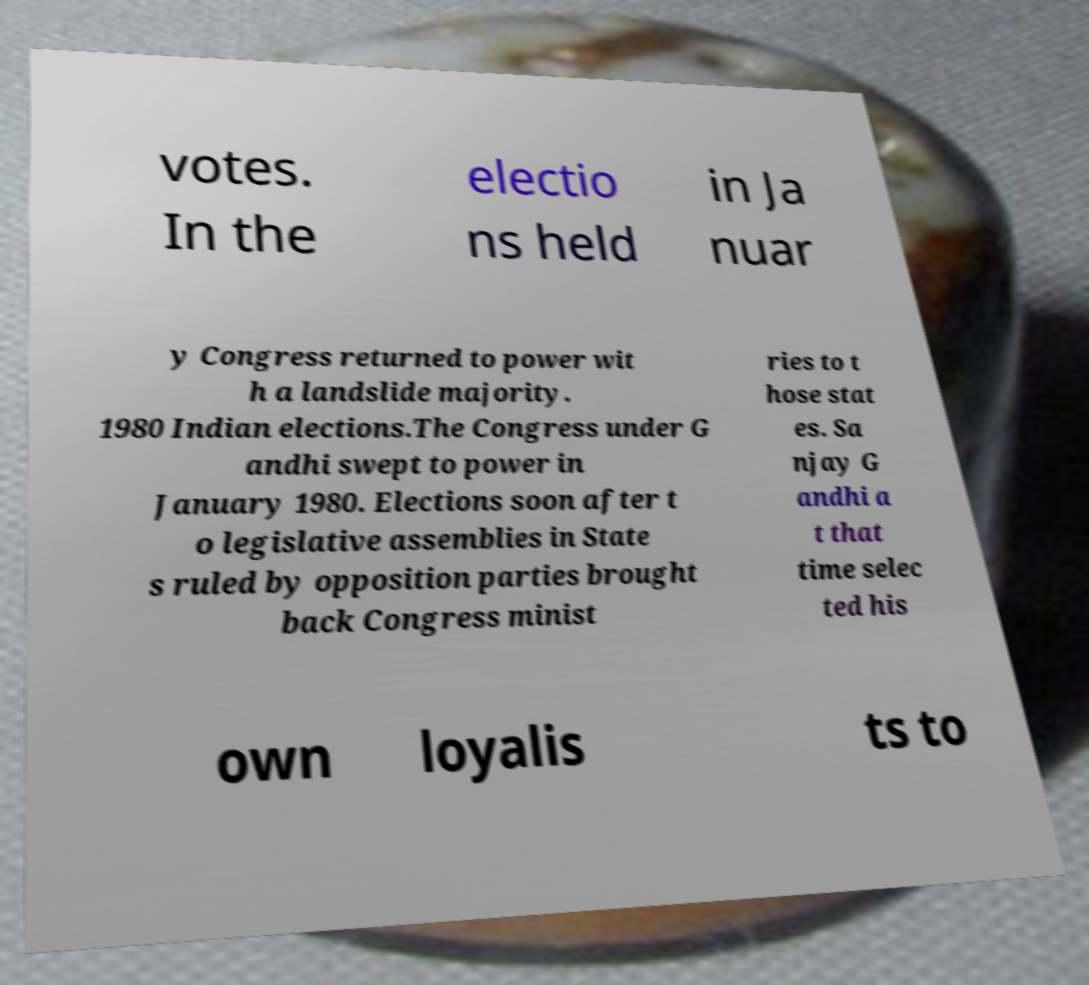Can you read and provide the text displayed in the image?This photo seems to have some interesting text. Can you extract and type it out for me? votes. In the electio ns held in Ja nuar y Congress returned to power wit h a landslide majority. 1980 Indian elections.The Congress under G andhi swept to power in January 1980. Elections soon after t o legislative assemblies in State s ruled by opposition parties brought back Congress minist ries to t hose stat es. Sa njay G andhi a t that time selec ted his own loyalis ts to 